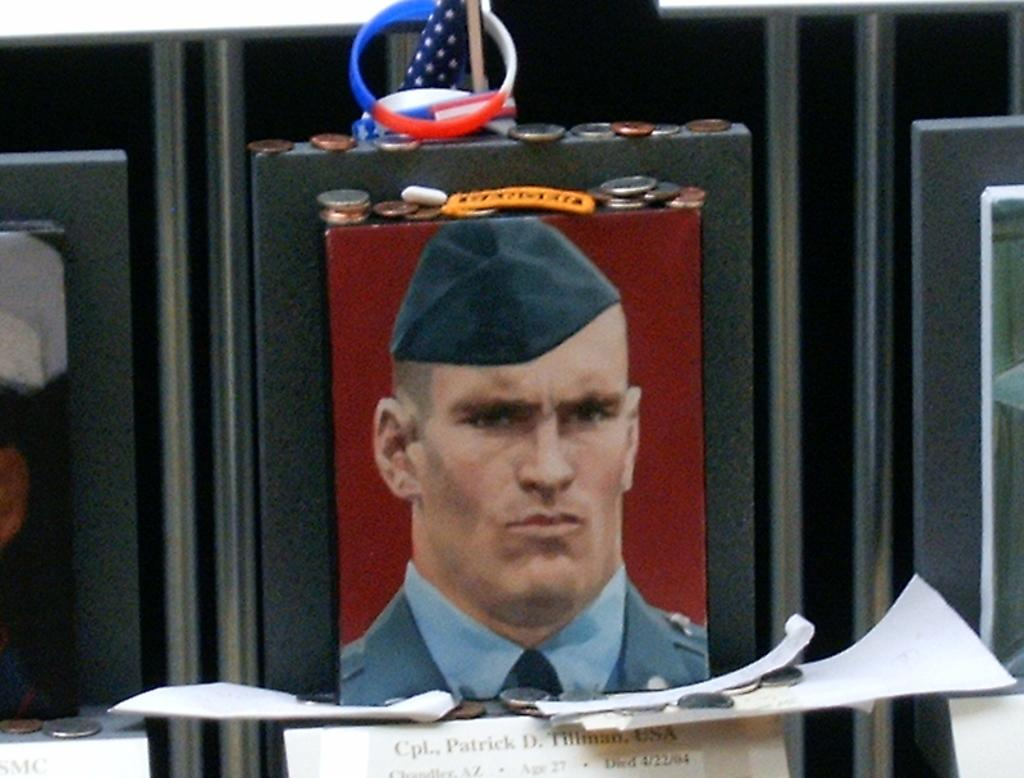What is the main subject of the image? The main subject of the image is a person's photo. What is the color of the surface the photo is attached to? The photo is attached to a black color surface. What other items can be seen in the image? Coins, a band, a flag, and papers are present in the image. What does the father smell like in the image? There is no father present in the image, and therefore no smell can be associated with him. 